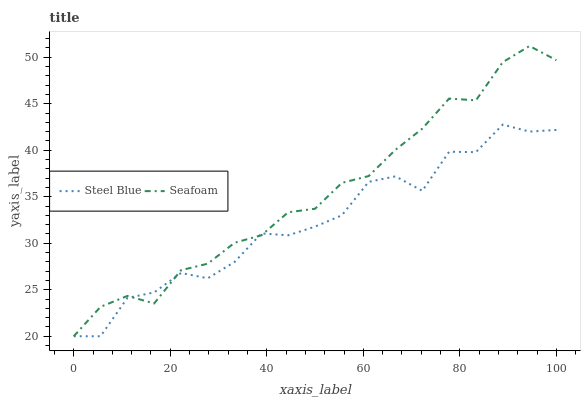Does Steel Blue have the minimum area under the curve?
Answer yes or no. Yes. Does Seafoam have the maximum area under the curve?
Answer yes or no. Yes. Does Seafoam have the minimum area under the curve?
Answer yes or no. No. Is Seafoam the smoothest?
Answer yes or no. Yes. Is Steel Blue the roughest?
Answer yes or no. Yes. Is Seafoam the roughest?
Answer yes or no. No. Does Steel Blue have the lowest value?
Answer yes or no. Yes. Does Seafoam have the highest value?
Answer yes or no. Yes. Does Seafoam intersect Steel Blue?
Answer yes or no. Yes. Is Seafoam less than Steel Blue?
Answer yes or no. No. Is Seafoam greater than Steel Blue?
Answer yes or no. No. 